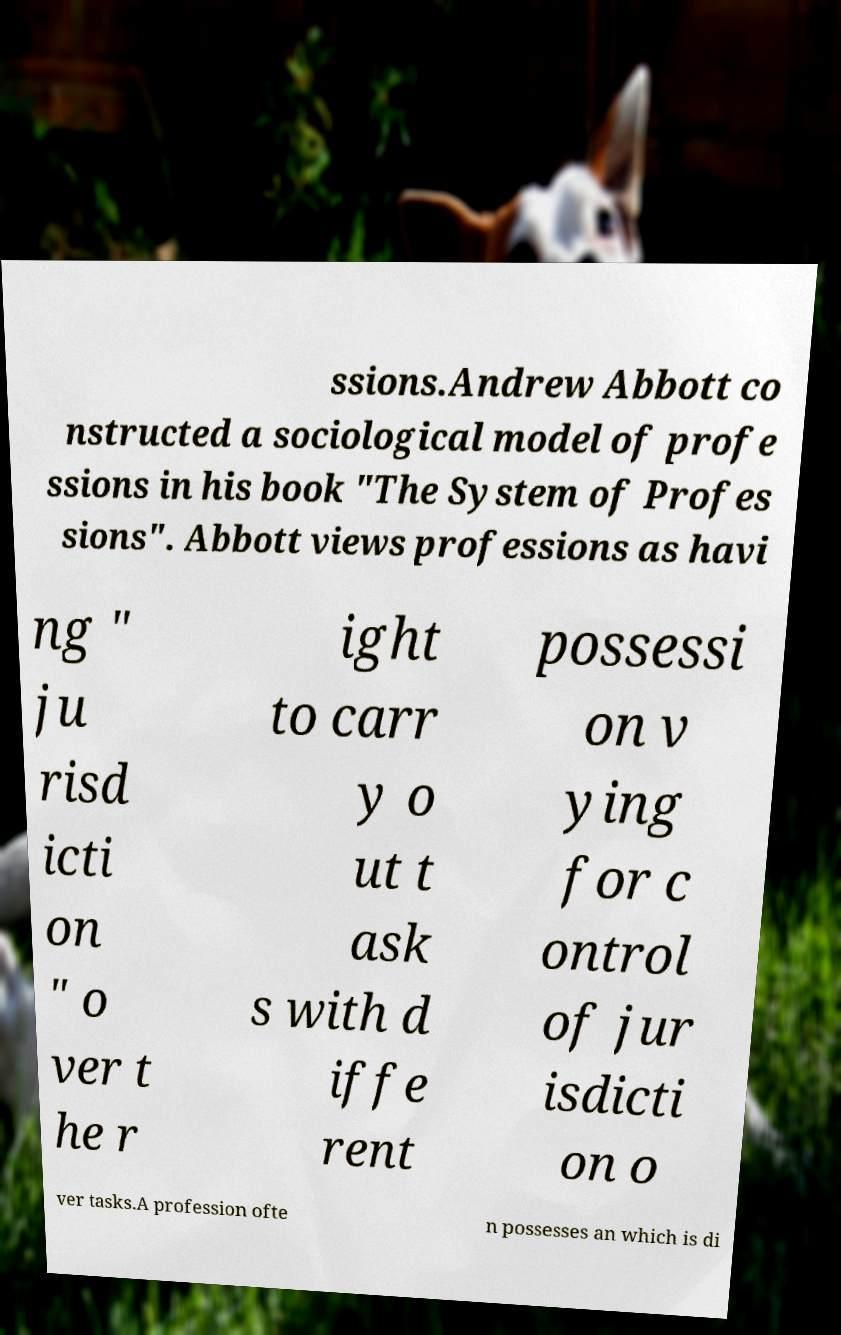Can you accurately transcribe the text from the provided image for me? ssions.Andrew Abbott co nstructed a sociological model of profe ssions in his book "The System of Profes sions". Abbott views professions as havi ng " ju risd icti on " o ver t he r ight to carr y o ut t ask s with d iffe rent possessi on v ying for c ontrol of jur isdicti on o ver tasks.A profession ofte n possesses an which is di 